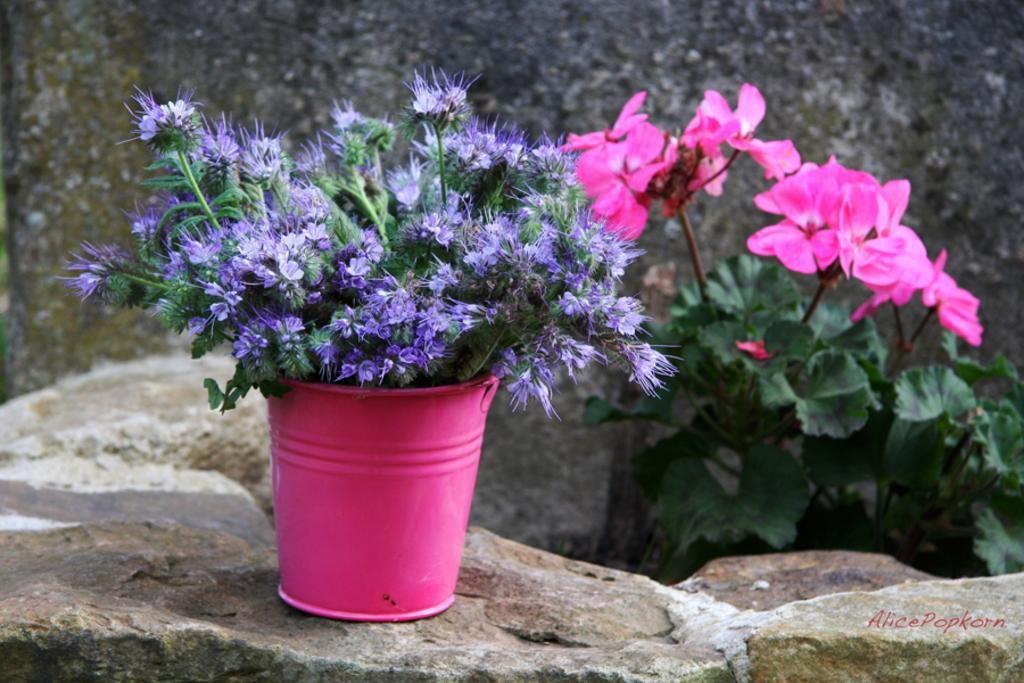In one or two sentences, can you explain what this image depicts? Here we can see plant with flowers in a bucket on the stone and on the right there is a plant with flowers. In the background we can see the wall. 